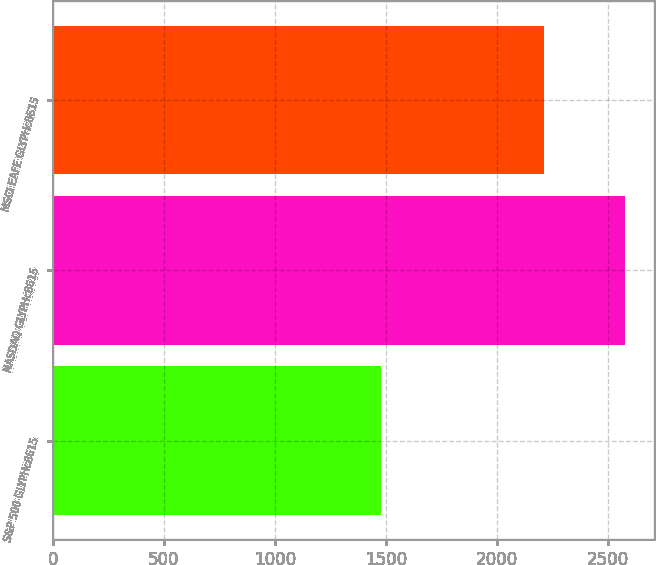<chart> <loc_0><loc_0><loc_500><loc_500><bar_chart><fcel>S&P 500 GLYPHc8615<fcel>NASDAQ GLYPHc8615<fcel>MSCI EAFE GLYPHc8615<nl><fcel>1477<fcel>2578<fcel>2212<nl></chart> 